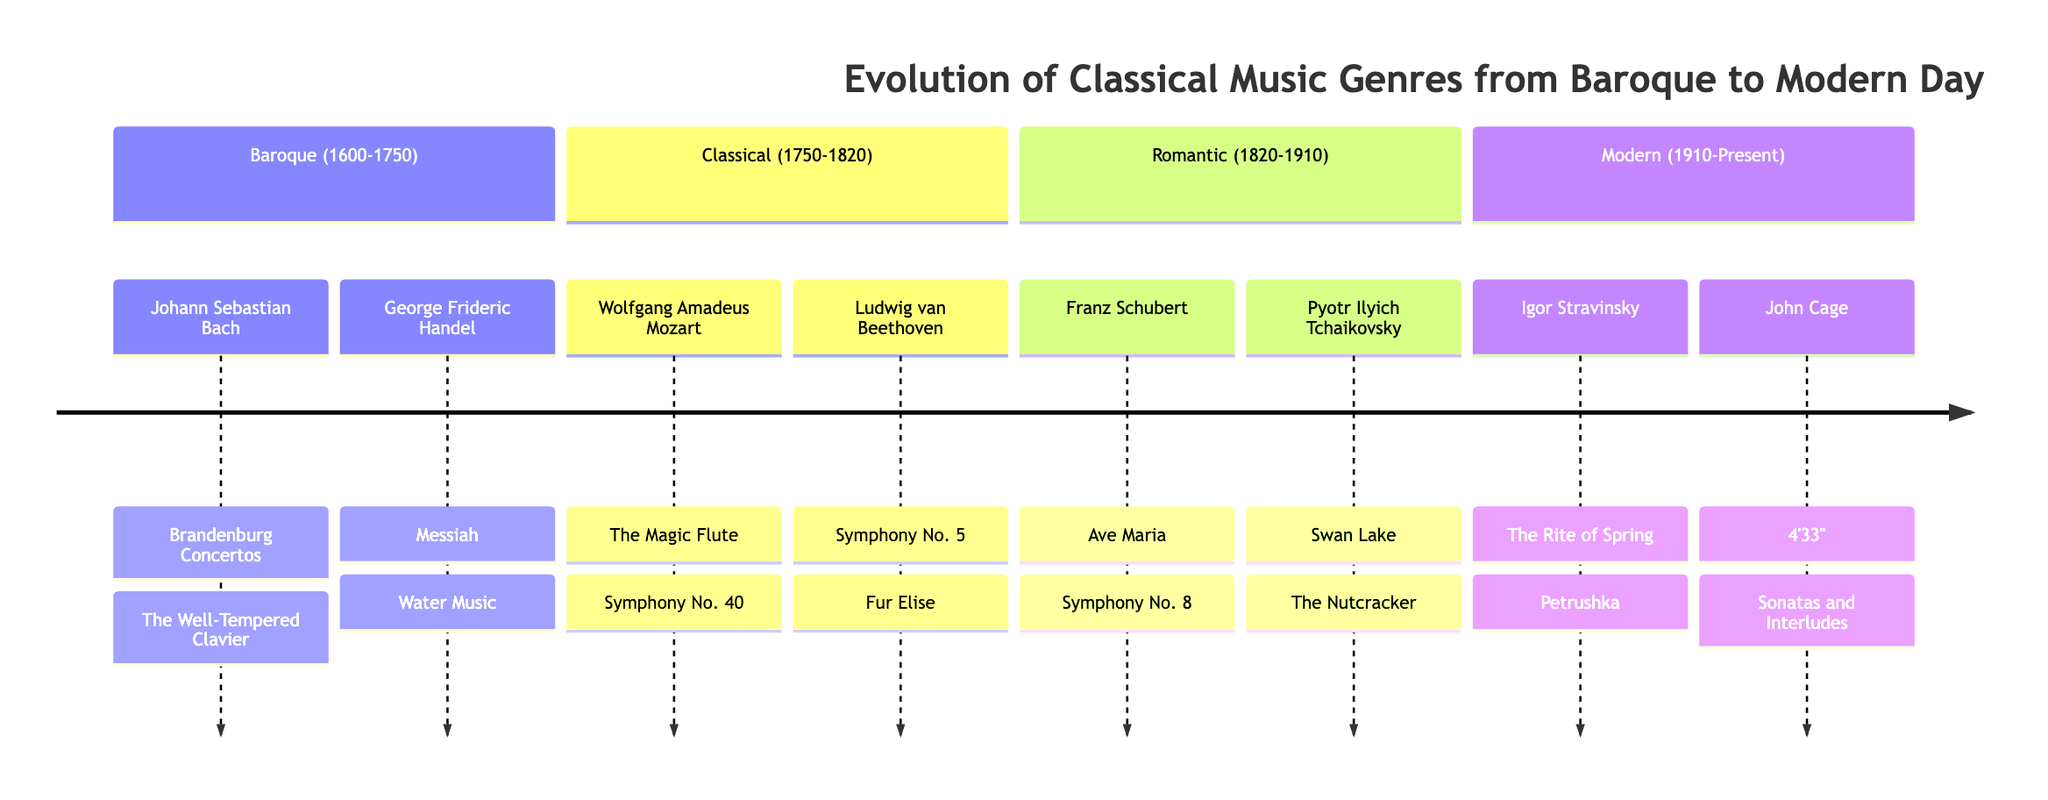What are the two key composers of the Baroque period? The diagram lists Johann Sebastian Bach and George Frideric Handel as the key composers of the Baroque period.
Answer: Johann Sebastian Bach, George Frideric Handel Which major work is associated with Ludwig van Beethoven? According to the diagram, Ludwig van Beethoven is associated with both "Symphony No. 5" and "Fur Elise", but the question specifically asks for a major work, referring to "Symphony No. 5" as one of his significant contributions.
Answer: Symphony No. 5 How many sections are there in the diagram? The diagram outlines four distinct sections: Baroque, Classical, Romantic, and Modern, which can be counted to determine the total number of sections.
Answer: 4 Which two composers are prominently featured in the Romantic period? From the diagram, the Romantic section includes Franz Schubert and Pyotr Ilyich Tchaikovsky as the highlighted composers, providing a direct answer to the inquiry about prominent figures in this era.
Answer: Franz Schubert, Pyotr Ilyich Tchaikovsky What genre does the work "The Rite of Spring" belong to? The diagram clearly indicates that "The Rite of Spring" is associated with Igor Stravinsky in the Modern period, aligning it with the Modern classical music genre.
Answer: Modern 